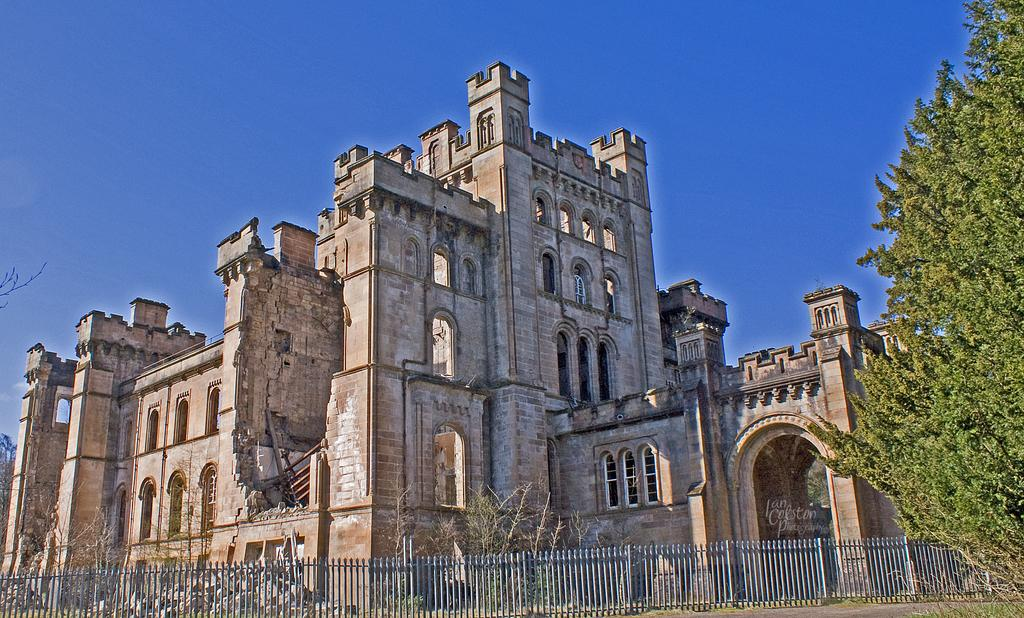What type of structure is in the image? There is a brown fort in the image. What feature can be seen on the fort? The fort has arch windows. What type of fencing is present at the front bottom side of the fort? There is an iron fencing grill at the front bottom side of the fort. What can be seen on the right side of the fort? There is a tree on the right side of the fort. What advice is the fort giving to the pest in the image? There is no pest present in the image, and the fort is not capable of giving advice. 